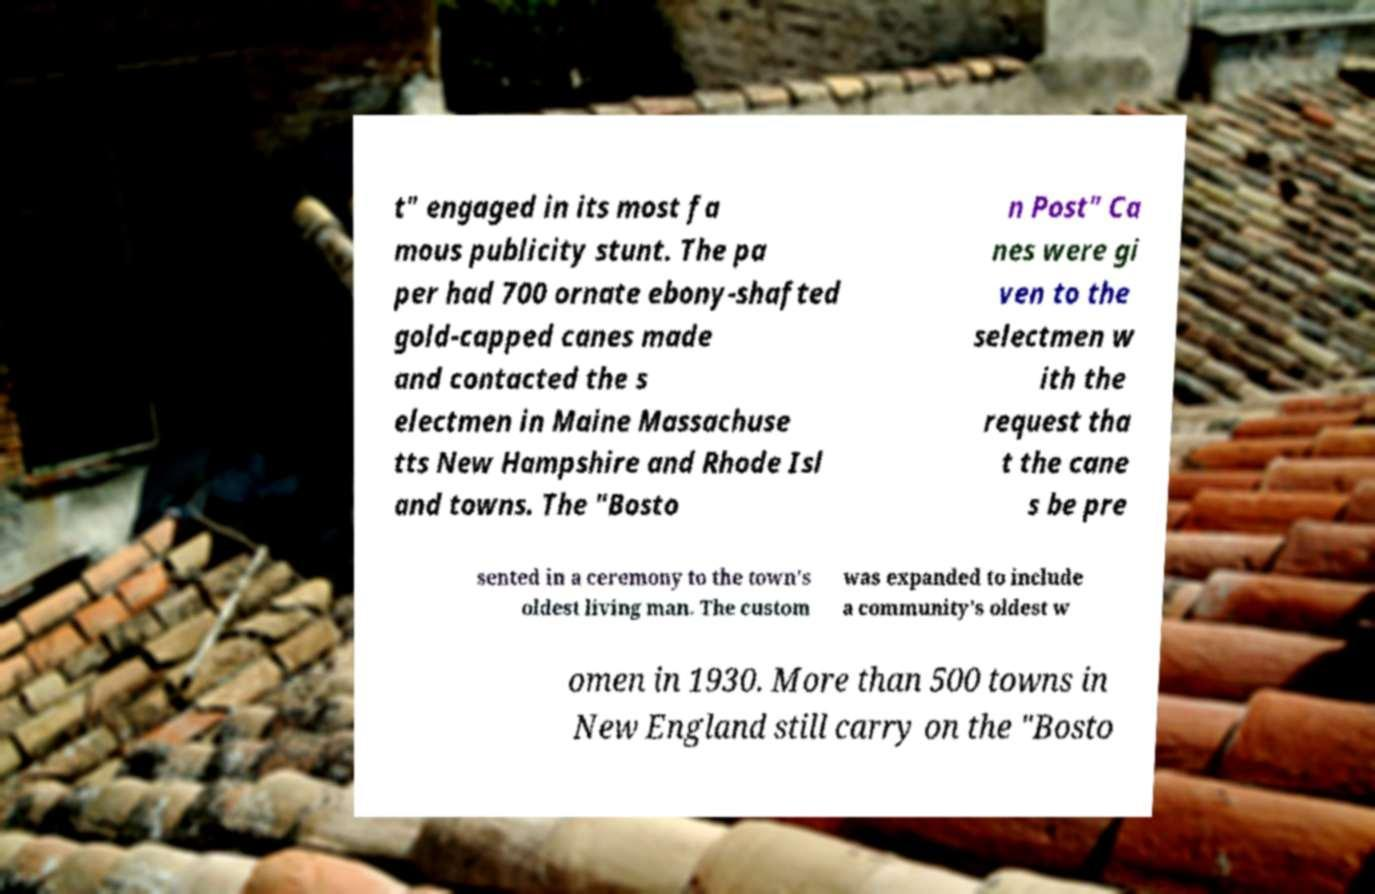Can you read and provide the text displayed in the image?This photo seems to have some interesting text. Can you extract and type it out for me? t" engaged in its most fa mous publicity stunt. The pa per had 700 ornate ebony-shafted gold-capped canes made and contacted the s electmen in Maine Massachuse tts New Hampshire and Rhode Isl and towns. The "Bosto n Post" Ca nes were gi ven to the selectmen w ith the request tha t the cane s be pre sented in a ceremony to the town's oldest living man. The custom was expanded to include a community's oldest w omen in 1930. More than 500 towns in New England still carry on the "Bosto 